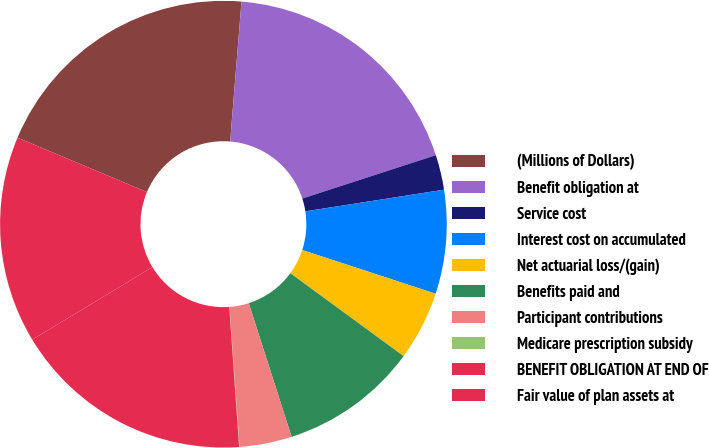Convert chart to OTSL. <chart><loc_0><loc_0><loc_500><loc_500><pie_chart><fcel>(Millions of Dollars)<fcel>Benefit obligation at<fcel>Service cost<fcel>Interest cost on accumulated<fcel>Net actuarial loss/(gain)<fcel>Benefits paid and<fcel>Participant contributions<fcel>Medicare prescription subsidy<fcel>BENEFIT OBLIGATION AT END OF<fcel>Fair value of plan assets at<nl><fcel>19.96%<fcel>18.71%<fcel>2.53%<fcel>7.51%<fcel>5.02%<fcel>10.0%<fcel>3.78%<fcel>0.04%<fcel>17.47%<fcel>14.98%<nl></chart> 